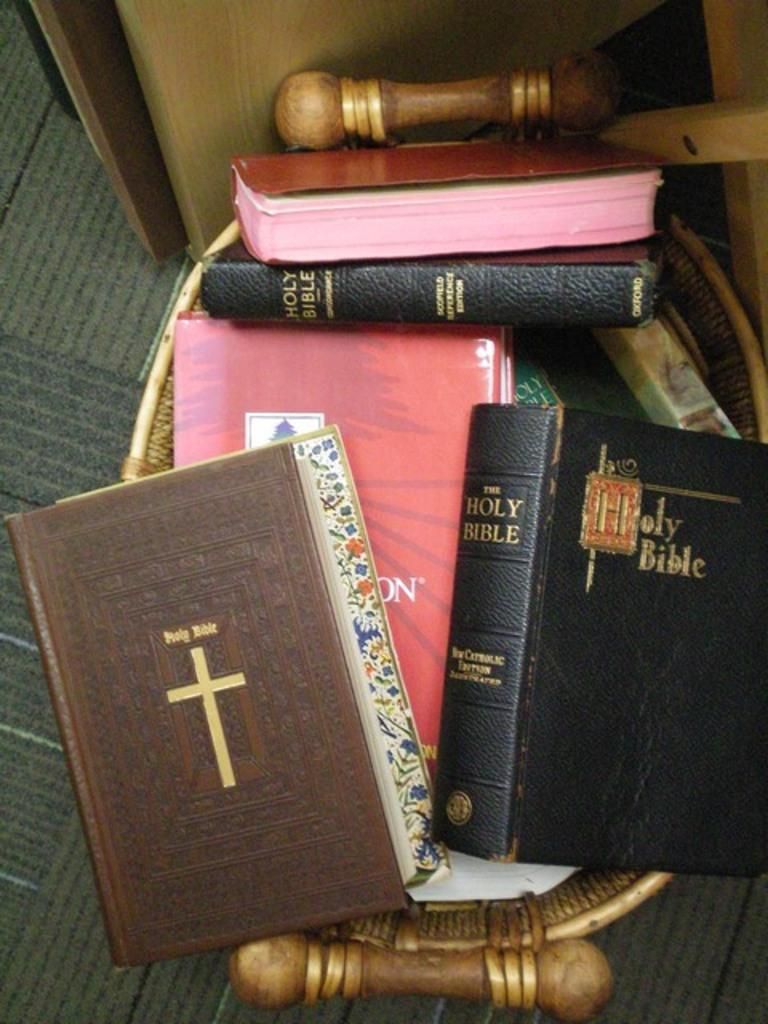<image>
Share a concise interpretation of the image provided. Bunch of Bibles are put inside a brown bin. 